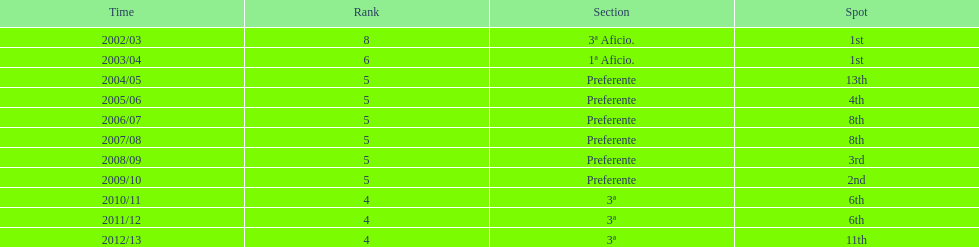How many times did internacional de madrid cf end the season at the top of their division? 2. 